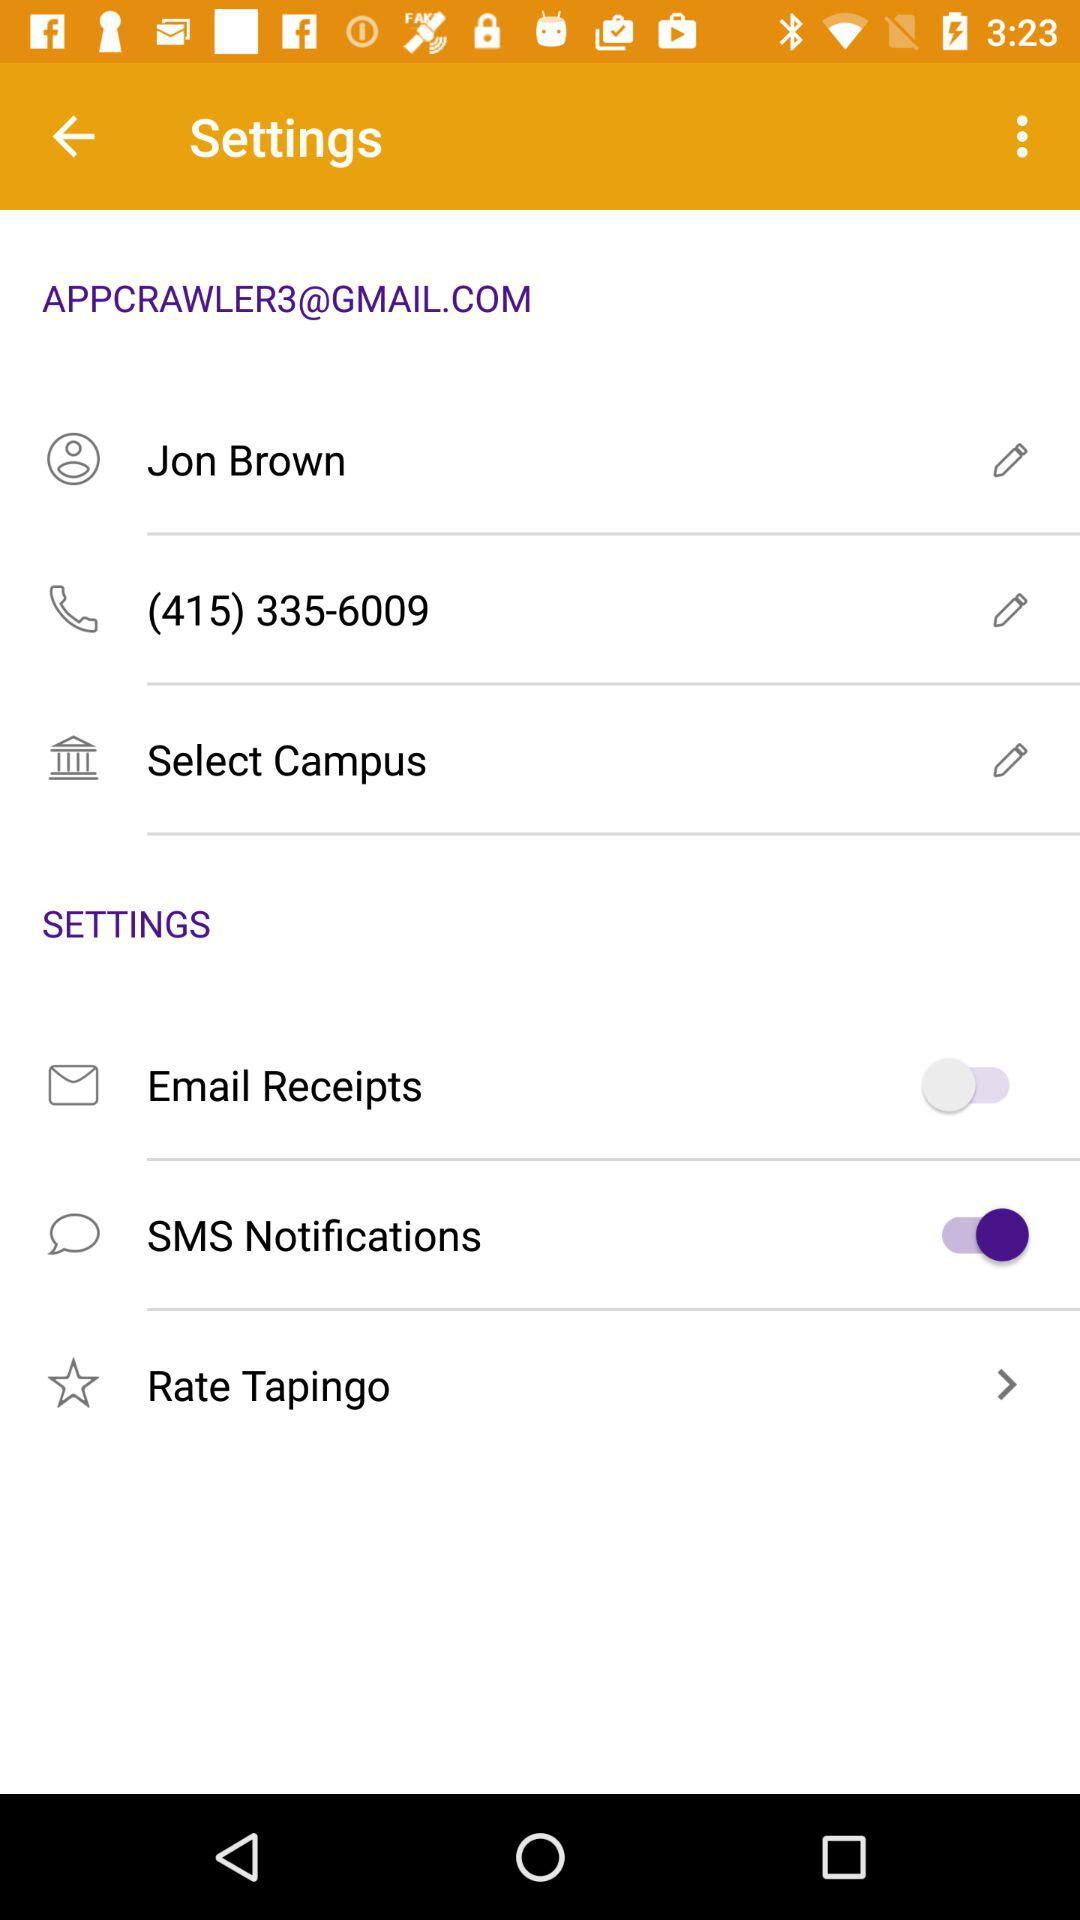What is the current status of the "Email Receipts"? The status is "off". 